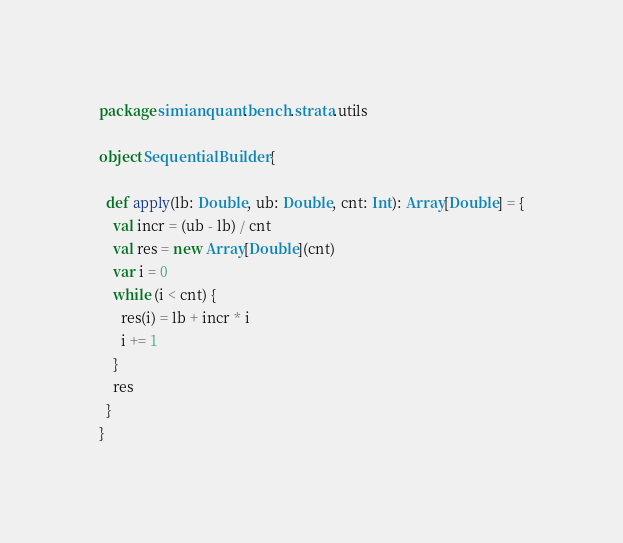Convert code to text. <code><loc_0><loc_0><loc_500><loc_500><_Scala_>package simianquant.bench.strata.utils

object SequentialBuilder {

  def apply(lb: Double, ub: Double, cnt: Int): Array[Double] = {
    val incr = (ub - lb) / cnt
    val res = new Array[Double](cnt)
    var i = 0
    while (i < cnt) {
      res(i) = lb + incr * i
      i += 1
    }
    res
  }
}
</code> 